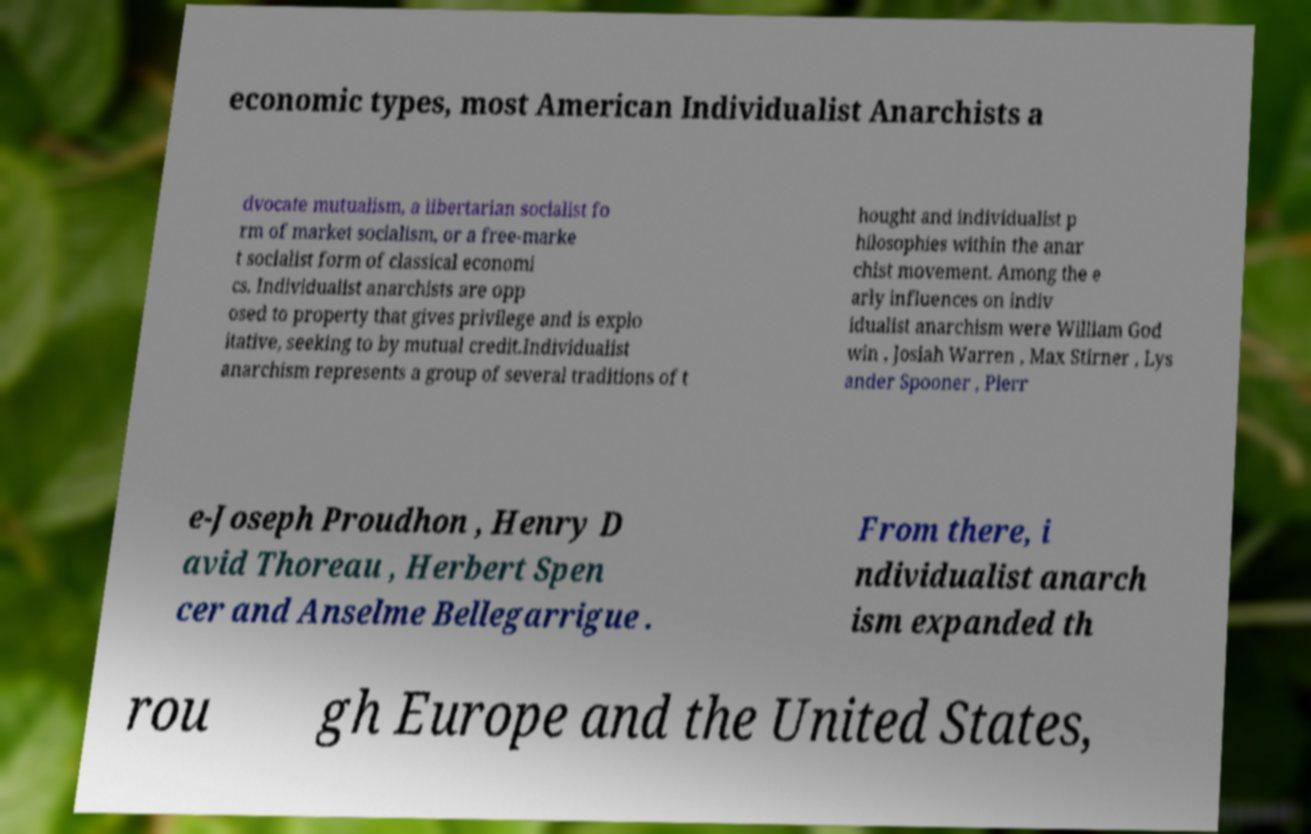What messages or text are displayed in this image? I need them in a readable, typed format. economic types, most American Individualist Anarchists a dvocate mutualism, a libertarian socialist fo rm of market socialism, or a free-marke t socialist form of classical economi cs. Individualist anarchists are opp osed to property that gives privilege and is explo itative, seeking to by mutual credit.Individualist anarchism represents a group of several traditions of t hought and individualist p hilosophies within the anar chist movement. Among the e arly influences on indiv idualist anarchism were William God win , Josiah Warren , Max Stirner , Lys ander Spooner , Pierr e-Joseph Proudhon , Henry D avid Thoreau , Herbert Spen cer and Anselme Bellegarrigue . From there, i ndividualist anarch ism expanded th rou gh Europe and the United States, 